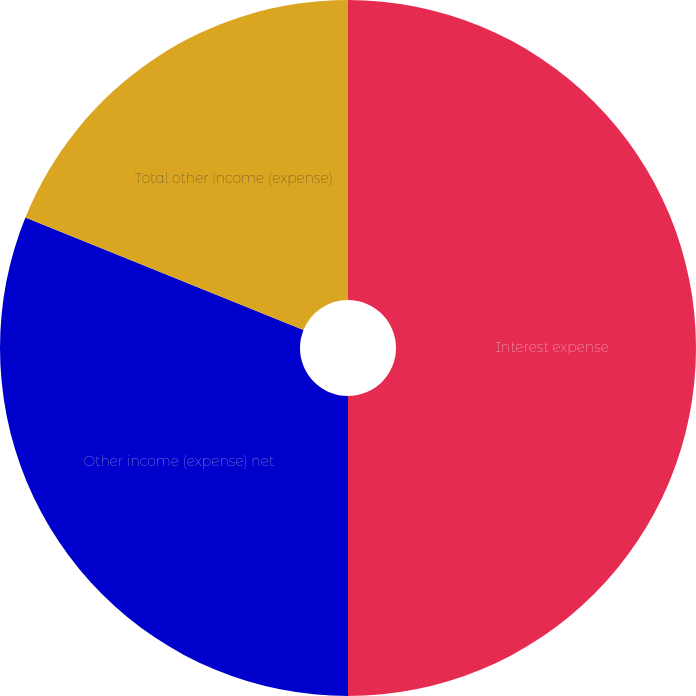<chart> <loc_0><loc_0><loc_500><loc_500><pie_chart><fcel>Interest expense<fcel>Other income (expense) net<fcel>Total other income (expense)<nl><fcel>50.0%<fcel>31.12%<fcel>18.88%<nl></chart> 